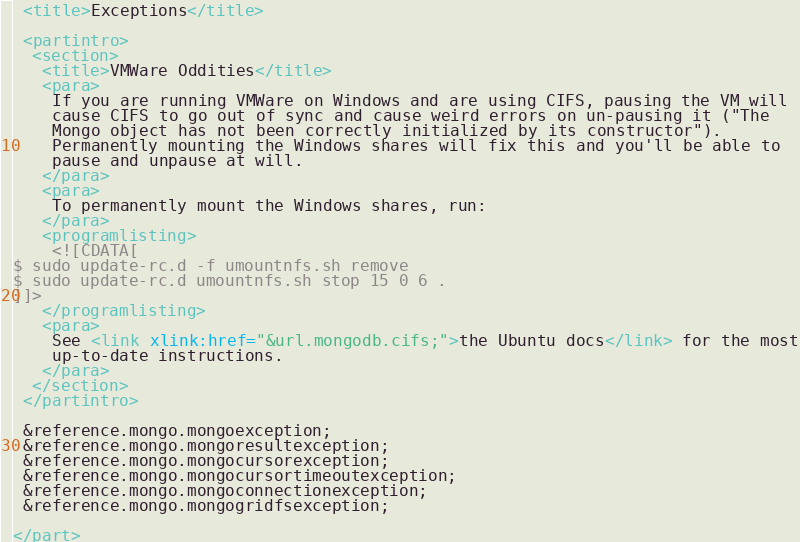Convert code to text. <code><loc_0><loc_0><loc_500><loc_500><_XML_>
 <title>Exceptions</title>

 <partintro>
  <section>
   <title>VMWare Oddities</title>
   <para>
    If you are running VMWare on Windows and are using CIFS, pausing the VM will 
    cause CIFS to go out of sync and cause weird errors on un-pausing it ("The 
    Mongo object has not been correctly initialized by its constructor").  
    Permanently mounting the Windows shares will fix this and you'll be able to
    pause and unpause at will.
   </para>
   <para>
    To permanently mount the Windows shares, run:
   </para>
   <programlisting>
    <![CDATA[
$ sudo update-rc.d -f umountnfs.sh remove
$ sudo update-rc.d umountnfs.sh stop 15 0 6 .
]]>
   </programlisting>
   <para>
    See <link xlink:href="&url.mongodb.cifs;">the Ubuntu docs</link> for the most
    up-to-date instructions.
   </para>
  </section>
 </partintro>

 &reference.mongo.mongoexception;
 &reference.mongo.mongoresultexception;
 &reference.mongo.mongocursorexception;
 &reference.mongo.mongocursortimeoutexception;
 &reference.mongo.mongoconnectionexception;
 &reference.mongo.mongogridfsexception;

</part>
</code> 